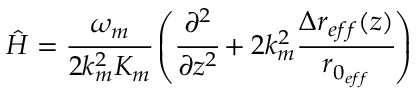Convert formula to latex. <formula><loc_0><loc_0><loc_500><loc_500>\hat { H } = \cfrac { \omega _ { m } } { 2 k _ { m } ^ { 2 } K _ { m } } \left ( \cfrac { \partial ^ { 2 } } { \partial z ^ { 2 } } + 2 k _ { m } ^ { 2 } \cfrac { \Delta r _ { e f f } ( z ) } { r _ { 0 _ { e f f } } } \right )</formula> 